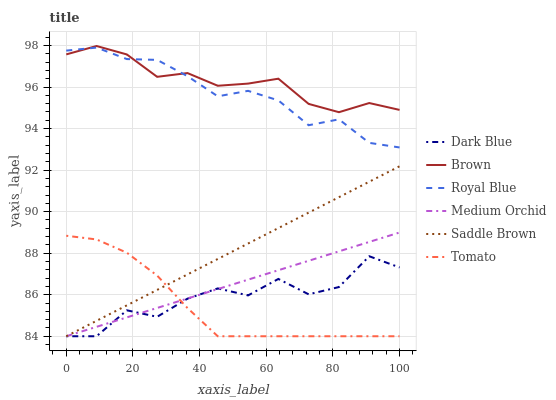Does Tomato have the minimum area under the curve?
Answer yes or no. Yes. Does Brown have the maximum area under the curve?
Answer yes or no. Yes. Does Royal Blue have the minimum area under the curve?
Answer yes or no. No. Does Royal Blue have the maximum area under the curve?
Answer yes or no. No. Is Saddle Brown the smoothest?
Answer yes or no. Yes. Is Dark Blue the roughest?
Answer yes or no. Yes. Is Brown the smoothest?
Answer yes or no. No. Is Brown the roughest?
Answer yes or no. No. Does Tomato have the lowest value?
Answer yes or no. Yes. Does Royal Blue have the lowest value?
Answer yes or no. No. Does Brown have the highest value?
Answer yes or no. Yes. Does Royal Blue have the highest value?
Answer yes or no. No. Is Saddle Brown less than Brown?
Answer yes or no. Yes. Is Royal Blue greater than Tomato?
Answer yes or no. Yes. Does Tomato intersect Saddle Brown?
Answer yes or no. Yes. Is Tomato less than Saddle Brown?
Answer yes or no. No. Is Tomato greater than Saddle Brown?
Answer yes or no. No. Does Saddle Brown intersect Brown?
Answer yes or no. No. 